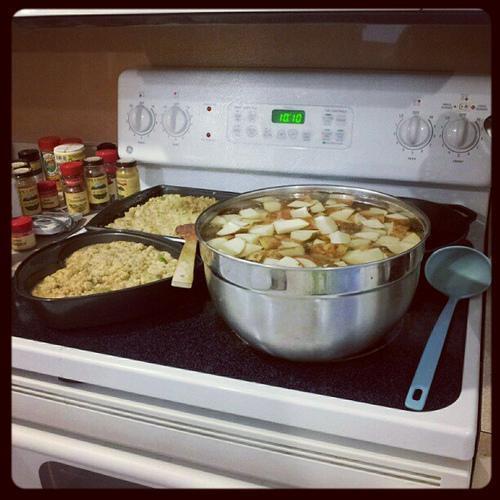How many bowls are there?
Give a very brief answer. 1. 